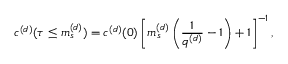<formula> <loc_0><loc_0><loc_500><loc_500>c ^ { ( d ) } ( \tau \leq m _ { s } ^ { ( d ) } ) = c ^ { ( d ) } ( 0 ) \left [ m _ { s } ^ { ( d ) } \left ( \frac { 1 } { q ^ { ( d ) } } - 1 \right ) + 1 \right ] ^ { - 1 } ,</formula> 